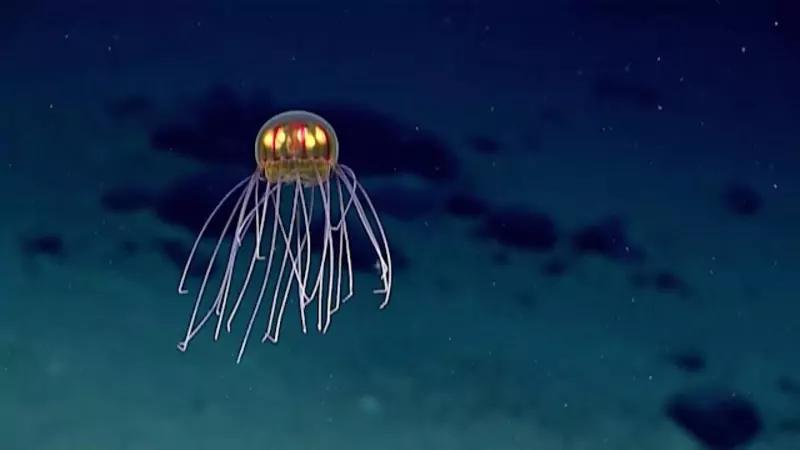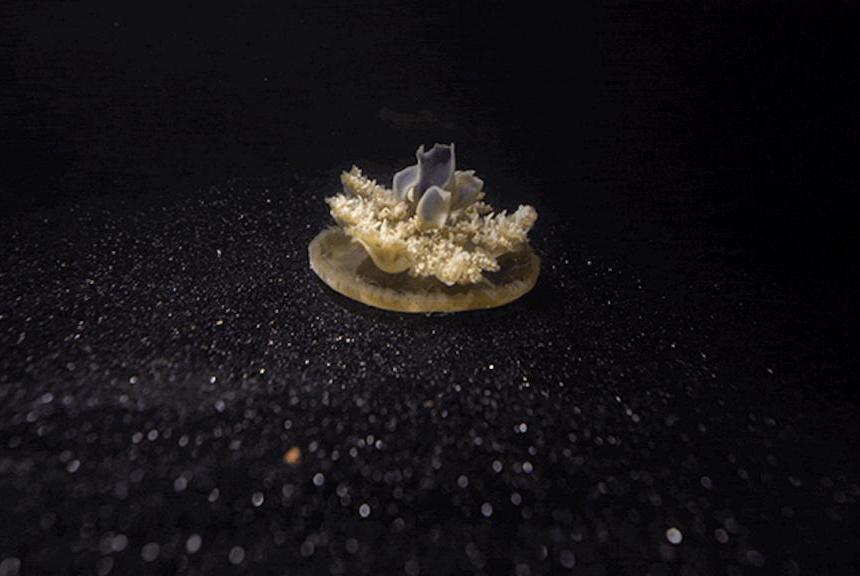The first image is the image on the left, the second image is the image on the right. For the images displayed, is the sentence "One image shows a single upside-down beige jellyfish with short tentacles extending upward from a saucer-shaped 'cap', and the other image shows a glowing yellowish jellyfish with long stringy tentacles trailing down from a dome 'cap'." factually correct? Answer yes or no. Yes. 